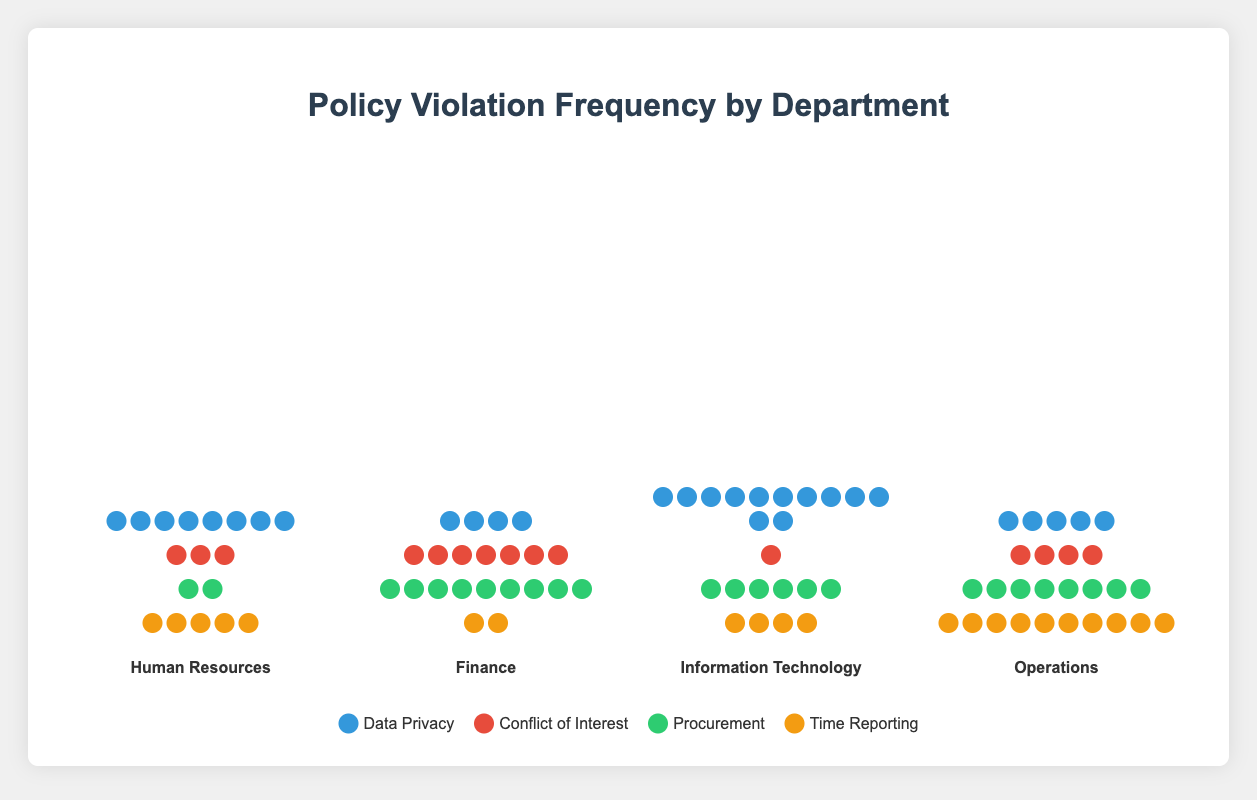What is the highest frequency of data privacy violations in a single department? Looking at the department sections, the icons representing data privacy violations (blue) have the highest count in Information Technology with 12 icons.
Answer: 12 Which department has the most conflict of interest violations? Check each department's section for the number of red icons representing conflict of interest violations. Finance has the most with 7 icons.
Answer: Finance What is the total number of procurement violations across all departments? Add up the green icons representing procurement violations for each department: 2 (HR) + 9 (Finance) + 6 (IT) + 8 (Operations) = 25
Answer: 25 How many more time reporting violations are there in Operations compared to Human Resources? Compare the count of orange icons representing time reporting violations in Operations and Human Resources: 10 (Operations) - 5 (HR) = 5 more violations in Operations.
Answer: 5 Which department has the least total number of policy violations? Sum the number of icons in each department section for total violations: HR (18), Finance (22), IT (23), Operations (27). Human Resources has the least with 18.
Answer: Human Resources Rank the departments by the number of data privacy violations from highest to lowest. Count the number of blue icons in each department and order them: IT (12), HR (8), Operations (5), Finance (4).
Answer: IT, HR, Operations, Finance Calculate the average number of policy violations per department for time reporting. Add the number of orange icons for each department and divide by the number of departments: (5 + 2 + 4 + 10) / 4 = 21 / 4 = 5.25
Answer: 5.25 Which two departments have the same number of data privacy violations? Compare the blue icon counts of each department. No two departments have the same number of data privacy violations.
Answer: None In which category are the most frequent violations occurring in the Finance department? Identify which color has the most icons in the Finance section. The green icons for procurement are the most frequent, counting 9.
Answer: Procurement 